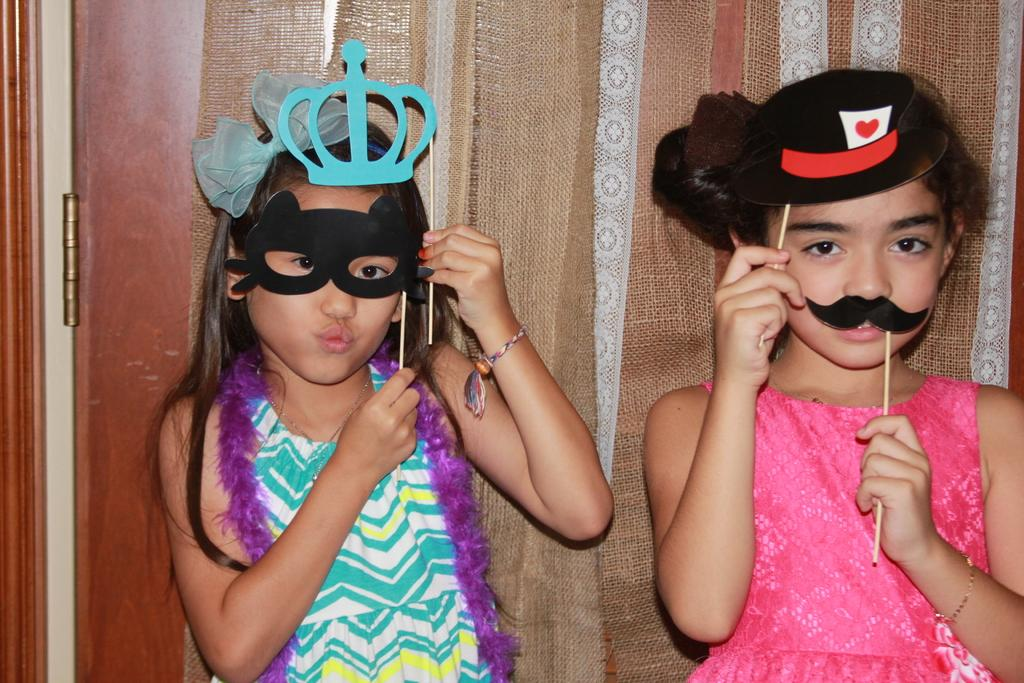How many children are present in the image? There are two children in the image. What are the children wearing on their faces? The children are wearing masks. What can be seen in the background of the image? There is a curtain in the background of the image. What type of pocket can be seen on the children's clothing in the image? There is no pocket visible on the children's clothing in the image. How many cats are present in the image? There are no cats present in the image. 